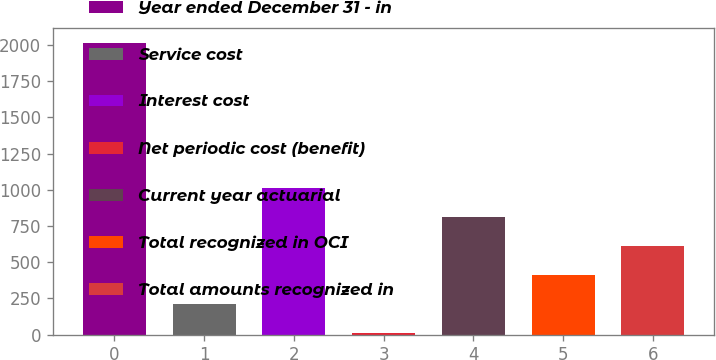Convert chart. <chart><loc_0><loc_0><loc_500><loc_500><bar_chart><fcel>Year ended December 31 - in<fcel>Service cost<fcel>Interest cost<fcel>Net periodic cost (benefit)<fcel>Current year actuarial<fcel>Total recognized in OCI<fcel>Total amounts recognized in<nl><fcel>2015<fcel>209.6<fcel>1012<fcel>9<fcel>811.4<fcel>410.2<fcel>610.8<nl></chart> 